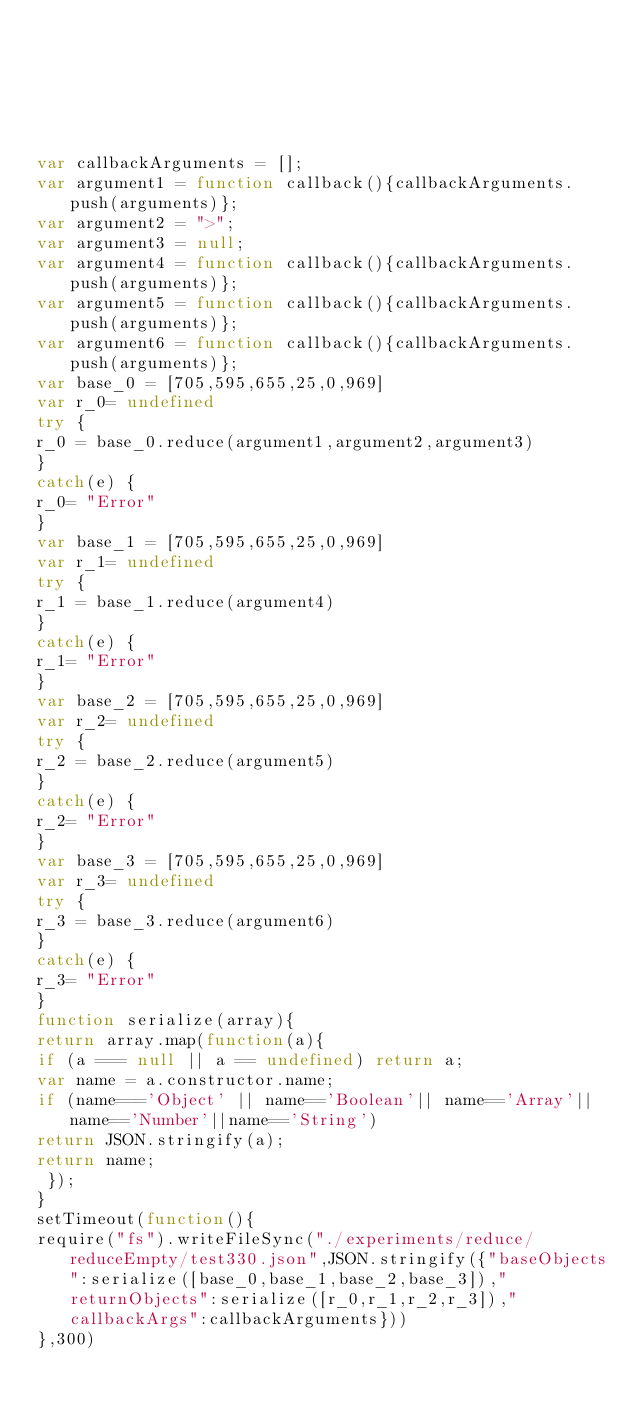Convert code to text. <code><loc_0><loc_0><loc_500><loc_500><_JavaScript_>





var callbackArguments = [];
var argument1 = function callback(){callbackArguments.push(arguments)};
var argument2 = ">";
var argument3 = null;
var argument4 = function callback(){callbackArguments.push(arguments)};
var argument5 = function callback(){callbackArguments.push(arguments)};
var argument6 = function callback(){callbackArguments.push(arguments)};
var base_0 = [705,595,655,25,0,969]
var r_0= undefined
try {
r_0 = base_0.reduce(argument1,argument2,argument3)
}
catch(e) {
r_0= "Error"
}
var base_1 = [705,595,655,25,0,969]
var r_1= undefined
try {
r_1 = base_1.reduce(argument4)
}
catch(e) {
r_1= "Error"
}
var base_2 = [705,595,655,25,0,969]
var r_2= undefined
try {
r_2 = base_2.reduce(argument5)
}
catch(e) {
r_2= "Error"
}
var base_3 = [705,595,655,25,0,969]
var r_3= undefined
try {
r_3 = base_3.reduce(argument6)
}
catch(e) {
r_3= "Error"
}
function serialize(array){
return array.map(function(a){
if (a === null || a == undefined) return a;
var name = a.constructor.name;
if (name==='Object' || name=='Boolean'|| name=='Array'||name=='Number'||name=='String')
return JSON.stringify(a);
return name;
 });
}
setTimeout(function(){
require("fs").writeFileSync("./experiments/reduce/reduceEmpty/test330.json",JSON.stringify({"baseObjects":serialize([base_0,base_1,base_2,base_3]),"returnObjects":serialize([r_0,r_1,r_2,r_3]),"callbackArgs":callbackArguments}))
},300)</code> 